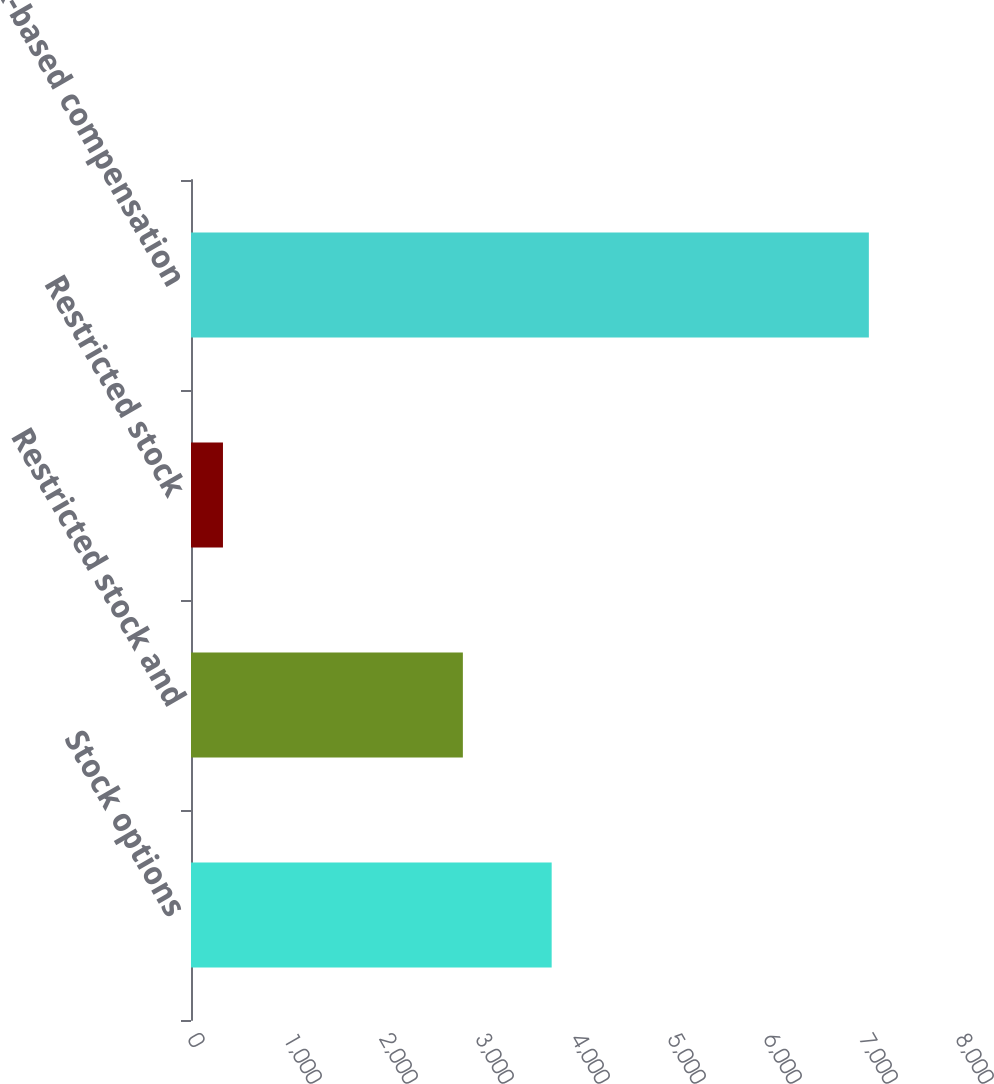Convert chart. <chart><loc_0><loc_0><loc_500><loc_500><bar_chart><fcel>Stock options<fcel>Restricted stock and<fcel>Restricted stock<fcel>Total stock-based compensation<nl><fcel>3757<fcel>2832<fcel>333<fcel>7061<nl></chart> 